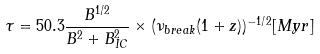<formula> <loc_0><loc_0><loc_500><loc_500>\tau = 5 0 . 3 \frac { B ^ { 1 \slash 2 } } { B ^ { 2 } + B ^ { 2 } _ { I C } } \times ( \nu _ { b r e a k } ( 1 + z ) ) ^ { - 1 \slash 2 } [ M y r ]</formula> 